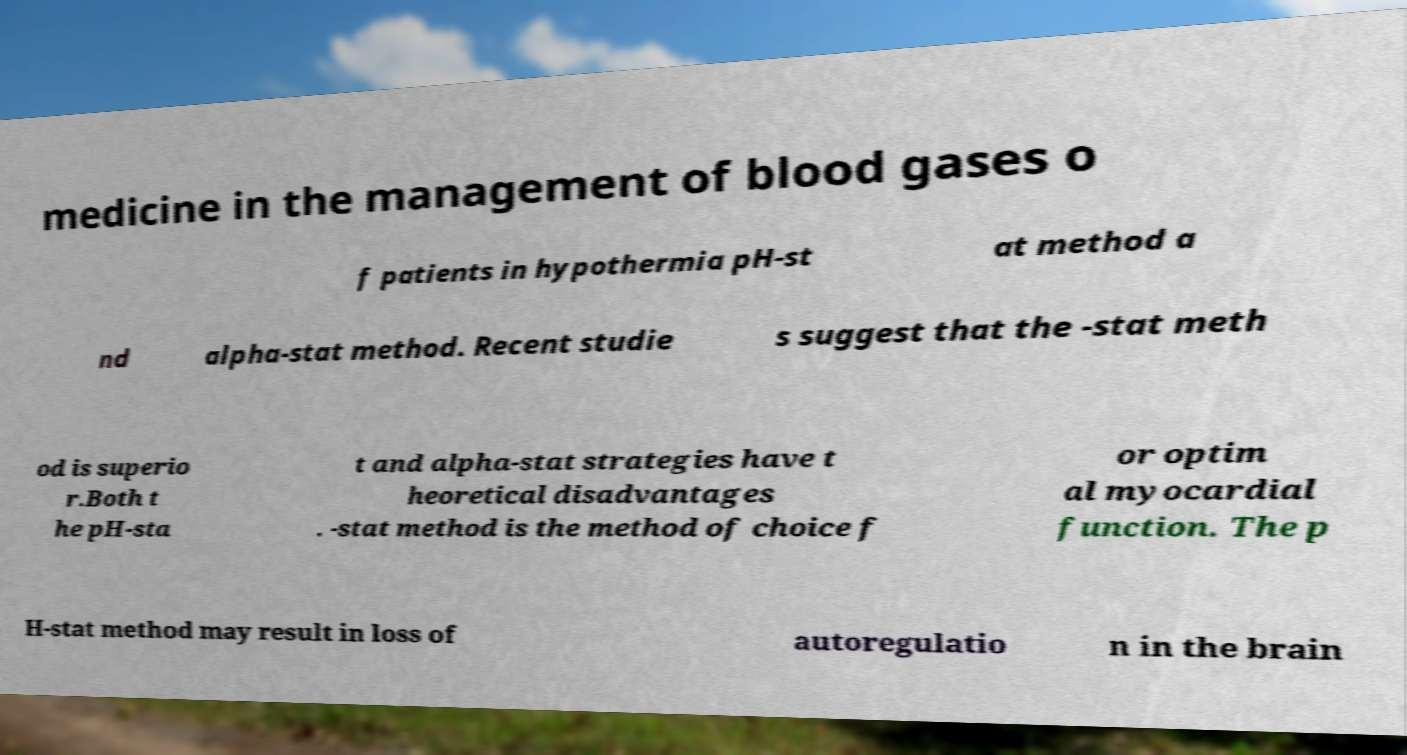For documentation purposes, I need the text within this image transcribed. Could you provide that? medicine in the management of blood gases o f patients in hypothermia pH-st at method a nd alpha-stat method. Recent studie s suggest that the -stat meth od is superio r.Both t he pH-sta t and alpha-stat strategies have t heoretical disadvantages . -stat method is the method of choice f or optim al myocardial function. The p H-stat method may result in loss of autoregulatio n in the brain 